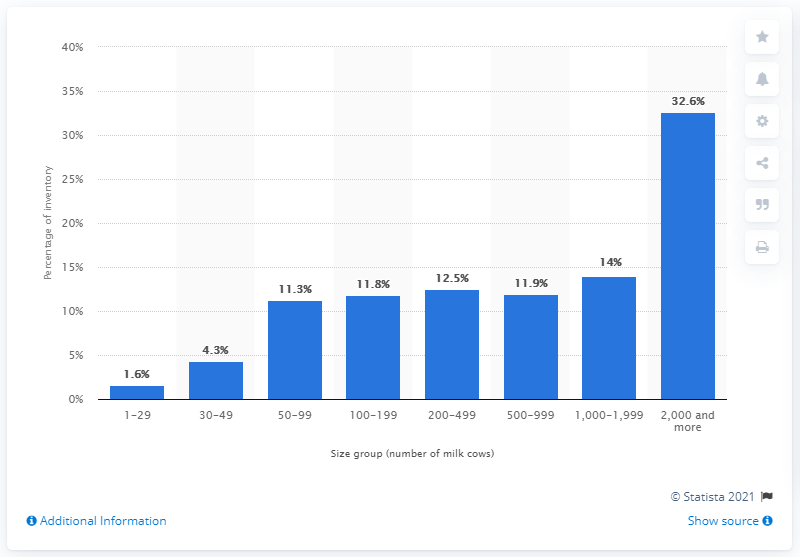Give some essential details in this illustration. In 2012, operations involving 30 to 49 milk cows accounted for 4.3% of the total milk cow inventory in the United States. 